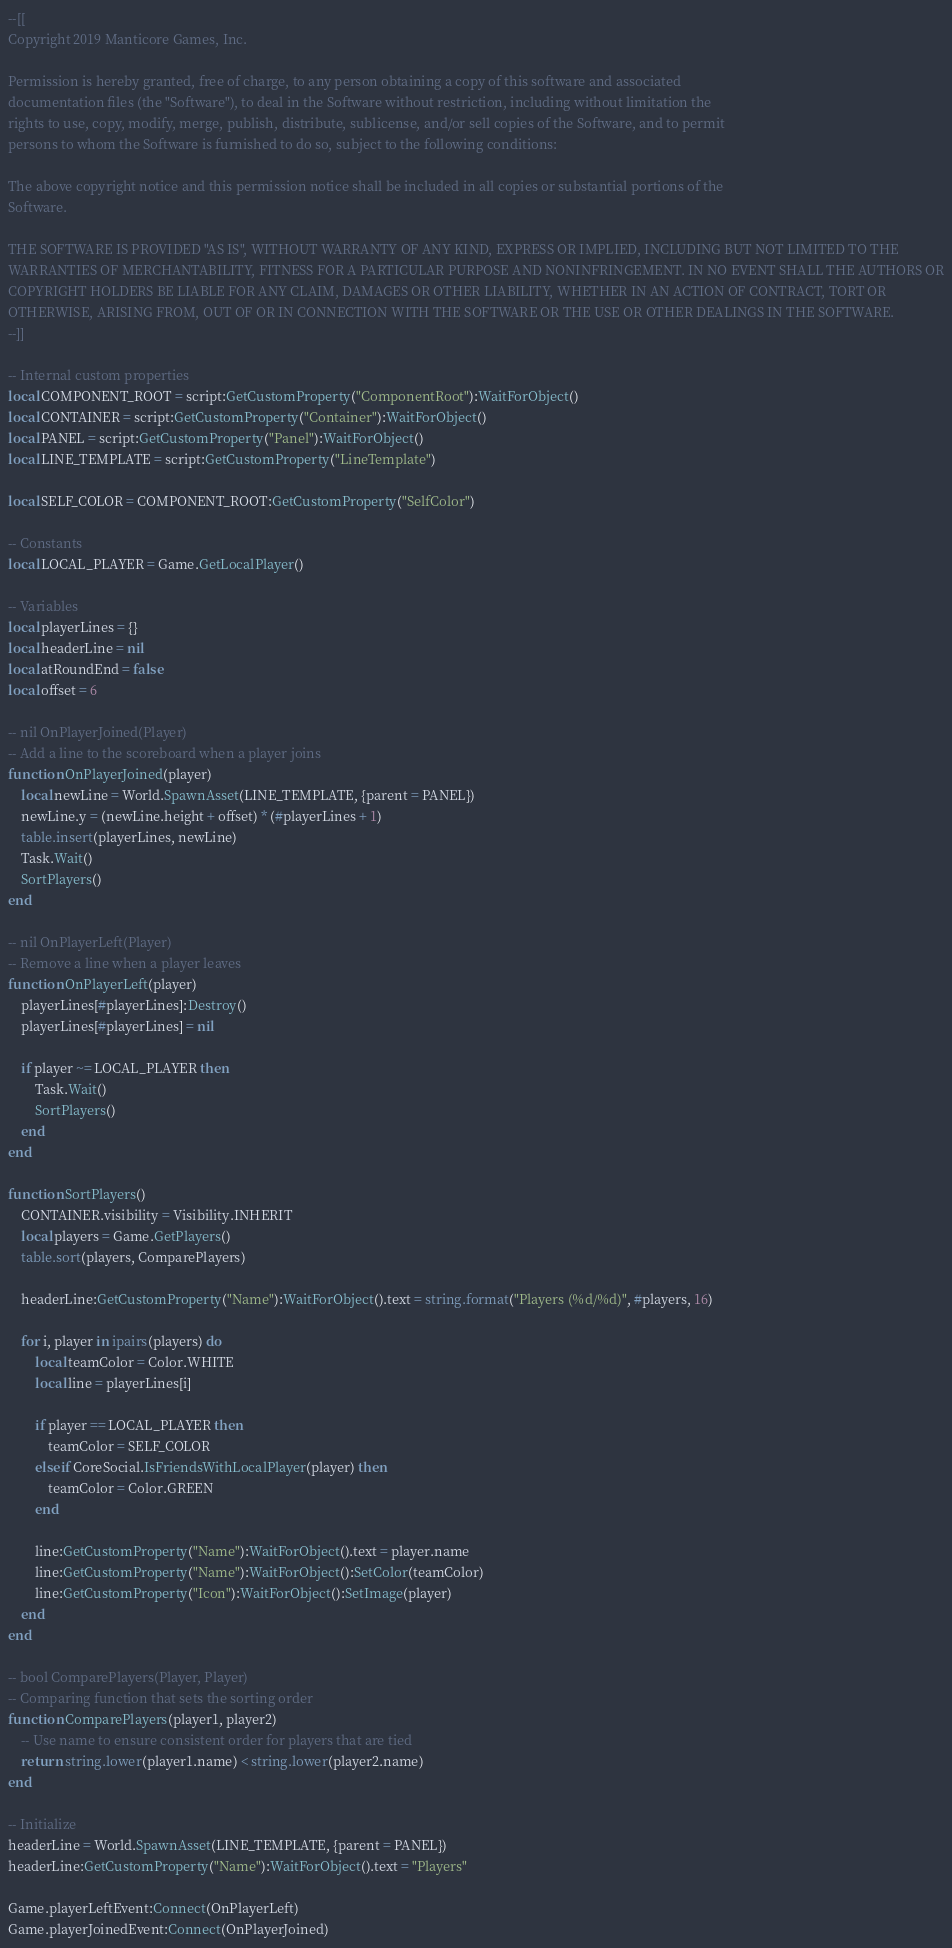<code> <loc_0><loc_0><loc_500><loc_500><_Lua_>--[[
Copyright 2019 Manticore Games, Inc.

Permission is hereby granted, free of charge, to any person obtaining a copy of this software and associated
documentation files (the "Software"), to deal in the Software without restriction, including without limitation the
rights to use, copy, modify, merge, publish, distribute, sublicense, and/or sell copies of the Software, and to permit
persons to whom the Software is furnished to do so, subject to the following conditions:

The above copyright notice and this permission notice shall be included in all copies or substantial portions of the
Software.

THE SOFTWARE IS PROVIDED "AS IS", WITHOUT WARRANTY OF ANY KIND, EXPRESS OR IMPLIED, INCLUDING BUT NOT LIMITED TO THE
WARRANTIES OF MERCHANTABILITY, FITNESS FOR A PARTICULAR PURPOSE AND NONINFRINGEMENT. IN NO EVENT SHALL THE AUTHORS OR
COPYRIGHT HOLDERS BE LIABLE FOR ANY CLAIM, DAMAGES OR OTHER LIABILITY, WHETHER IN AN ACTION OF CONTRACT, TORT OR
OTHERWISE, ARISING FROM, OUT OF OR IN CONNECTION WITH THE SOFTWARE OR THE USE OR OTHER DEALINGS IN THE SOFTWARE.
--]]

-- Internal custom properties
local COMPONENT_ROOT = script:GetCustomProperty("ComponentRoot"):WaitForObject()
local CONTAINER = script:GetCustomProperty("Container"):WaitForObject()
local PANEL = script:GetCustomProperty("Panel"):WaitForObject()
local LINE_TEMPLATE = script:GetCustomProperty("LineTemplate")

local SELF_COLOR = COMPONENT_ROOT:GetCustomProperty("SelfColor")

-- Constants
local LOCAL_PLAYER = Game.GetLocalPlayer()

-- Variables
local playerLines = {}
local headerLine = nil
local atRoundEnd = false
local offset = 6

-- nil OnPlayerJoined(Player)
-- Add a line to the scoreboard when a player joins
function OnPlayerJoined(player)
    local newLine = World.SpawnAsset(LINE_TEMPLATE, {parent = PANEL})
    newLine.y = (newLine.height + offset) * (#playerLines + 1)
    table.insert(playerLines, newLine)
    Task.Wait()
    SortPlayers()
end

-- nil OnPlayerLeft(Player)
-- Remove a line when a player leaves
function OnPlayerLeft(player)
    playerLines[#playerLines]:Destroy()
    playerLines[#playerLines] = nil

    if player ~= LOCAL_PLAYER then
        Task.Wait()
        SortPlayers()
    end
end

function SortPlayers()
    CONTAINER.visibility = Visibility.INHERIT
    local players = Game.GetPlayers()
    table.sort(players, ComparePlayers)

    headerLine:GetCustomProperty("Name"):WaitForObject().text = string.format("Players (%d/%d)", #players, 16)

    for i, player in ipairs(players) do
        local teamColor = Color.WHITE
        local line = playerLines[i]

        if player == LOCAL_PLAYER then
            teamColor = SELF_COLOR
        elseif CoreSocial.IsFriendsWithLocalPlayer(player) then
            teamColor = Color.GREEN
        end

        line:GetCustomProperty("Name"):WaitForObject().text = player.name
        line:GetCustomProperty("Name"):WaitForObject():SetColor(teamColor)
        line:GetCustomProperty("Icon"):WaitForObject():SetImage(player)
    end
end

-- bool ComparePlayers(Player, Player)
-- Comparing function that sets the sorting order
function ComparePlayers(player1, player2)
    -- Use name to ensure consistent order for players that are tied
    return string.lower(player1.name) < string.lower(player2.name)
end

-- Initialize
headerLine = World.SpawnAsset(LINE_TEMPLATE, {parent = PANEL})
headerLine:GetCustomProperty("Name"):WaitForObject().text = "Players"

Game.playerLeftEvent:Connect(OnPlayerLeft)
Game.playerJoinedEvent:Connect(OnPlayerJoined)</code> 